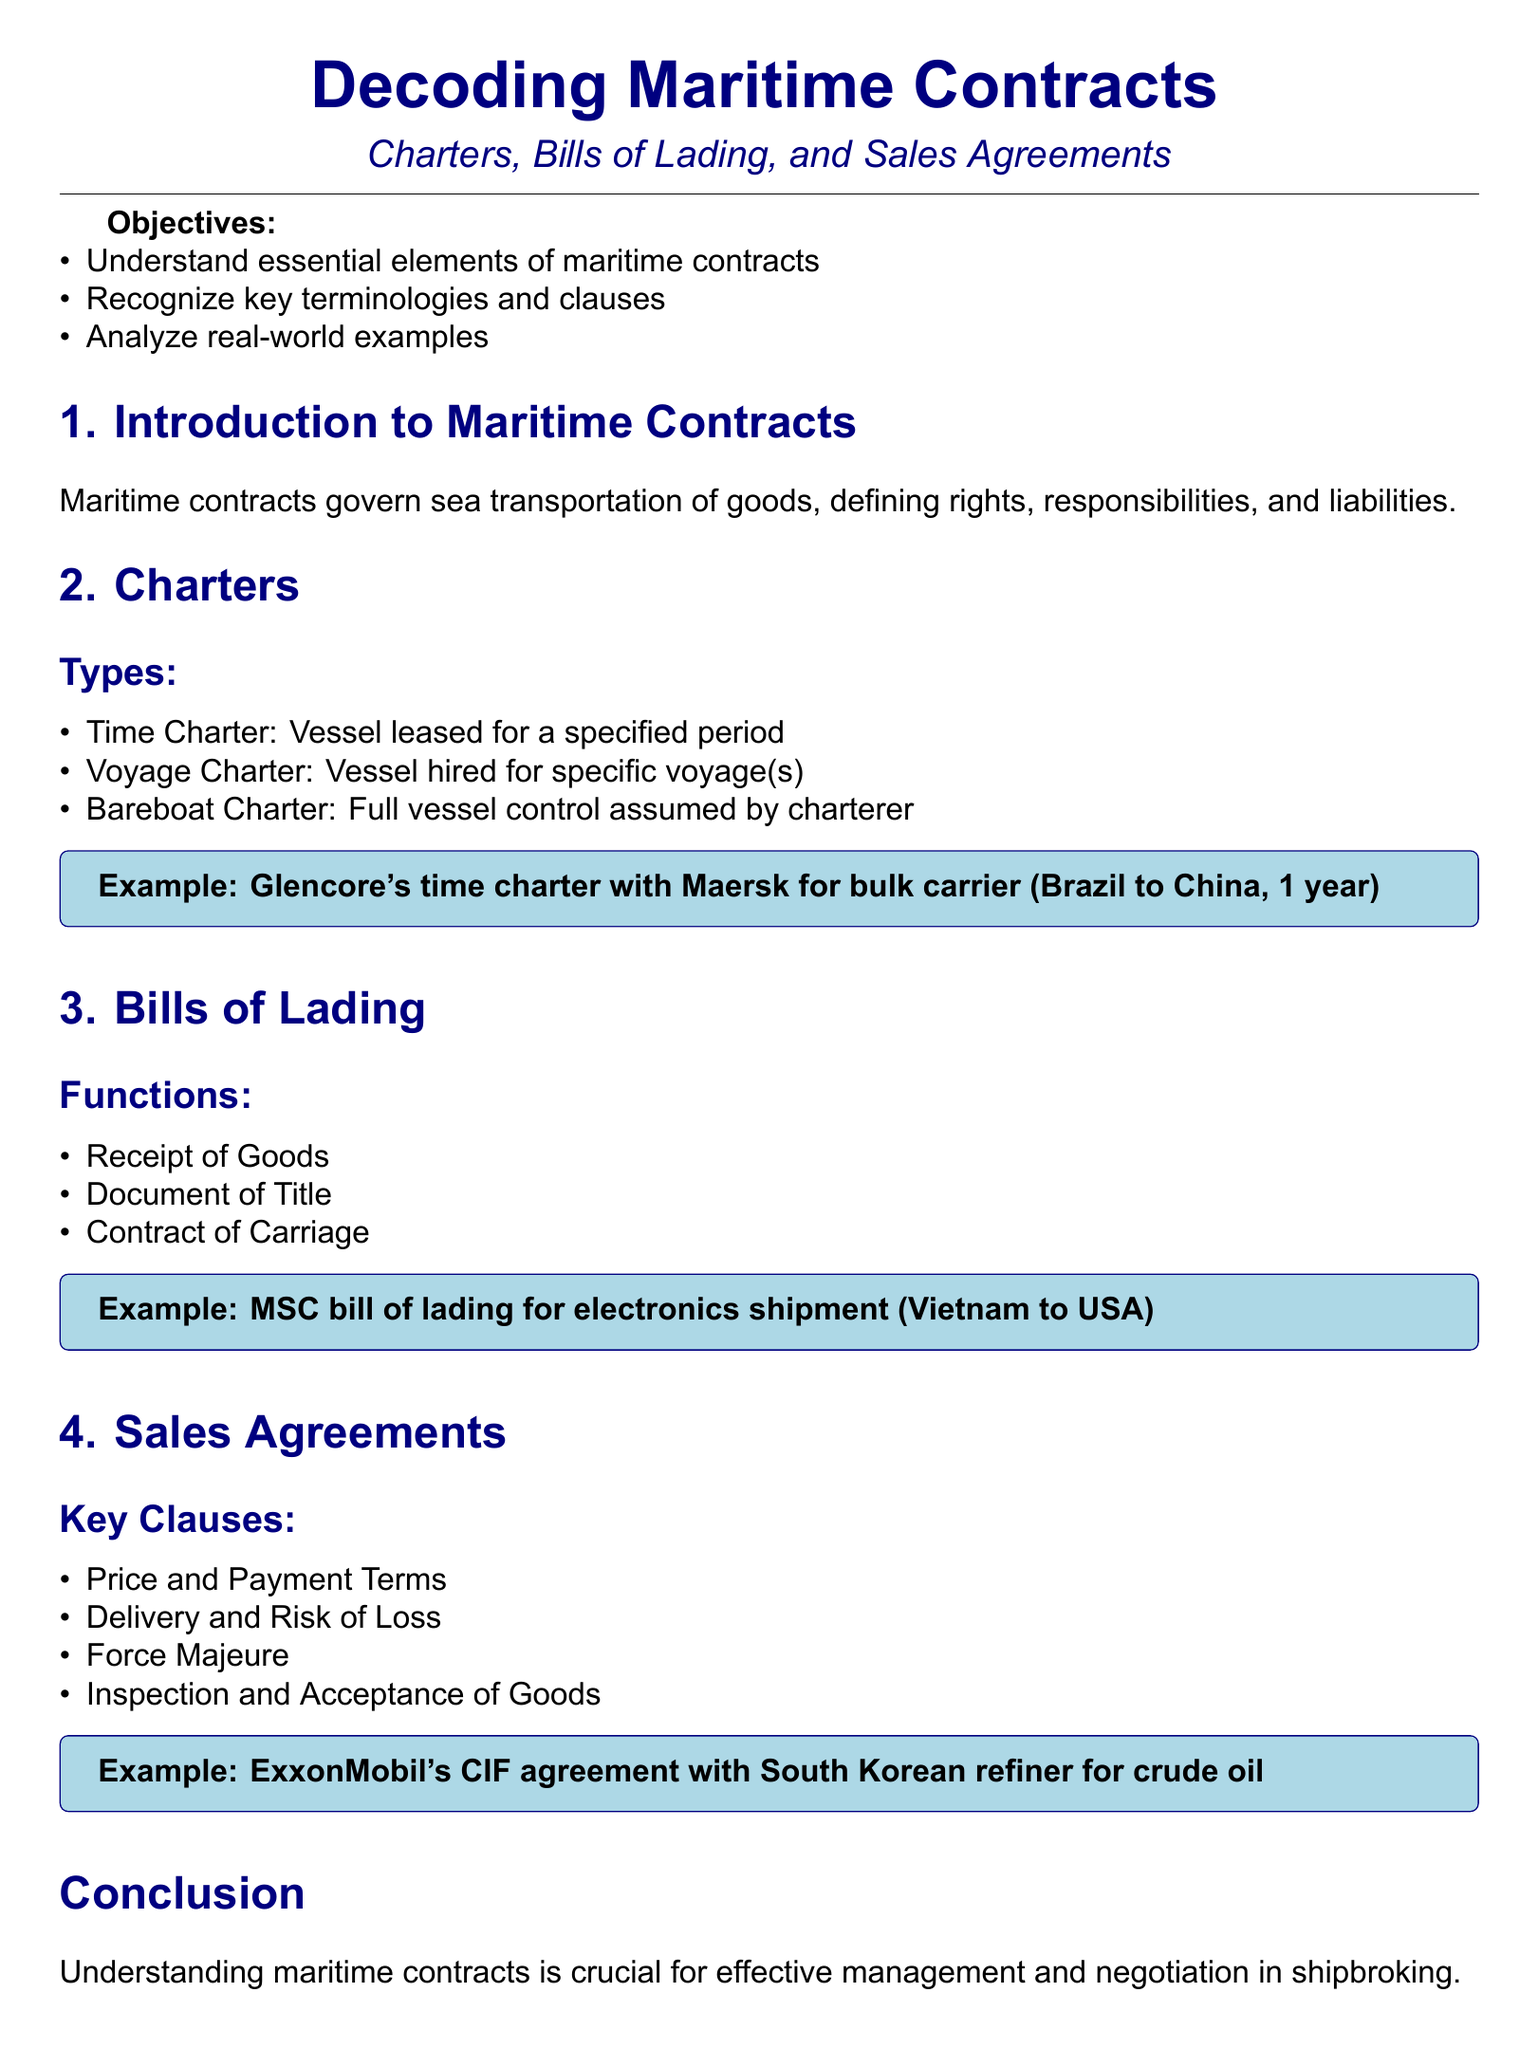What are the three types of charters? The document lists three types of charters under the section "Types" in Charters.
Answer: Time Charter, Voyage Charter, Bareboat Charter What is an example of a time charter? The document provides an example of a time charter with Glencore and Maersk for a specific vessel operation.
Answer: Glencore's time charter with Maersk for bulk carrier What is the function of a Bill of Lading? The document explains that a Bill of Lading serves three main functions.
Answer: Receipt of Goods, Document of Title, Contract of Carriage What is a key clause in Sales Agreements? The document outlines important clauses in Sales Agreements, listing several.
Answer: Price and Payment Terms Who is mentioned in the example of a CIF agreement? The document specifies an example of a CIF agreement relevant to crude oil trade.
Answer: ExxonMobil What is one suggested reading from the document? The document lists suggested readings that can enhance knowledge of maritime contracts.
Answer: Shipping Law by Simon Baughen Why are maritime contracts important in shipbroking? The conclusion of the document emphasizes the significance of understanding maritime contracts for shipbroking activities.
Answer: Effective management and negotiation What does a Voyage Charter refer to? The Types section of Charters describes what a Voyage Charter entails.
Answer: Vessel hired for specific voyage(s) 